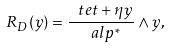<formula> <loc_0><loc_0><loc_500><loc_500>R _ { D } ( y ) = \frac { \ t e t + \eta y } { \ a l p ^ { * } } \wedge y ,</formula> 